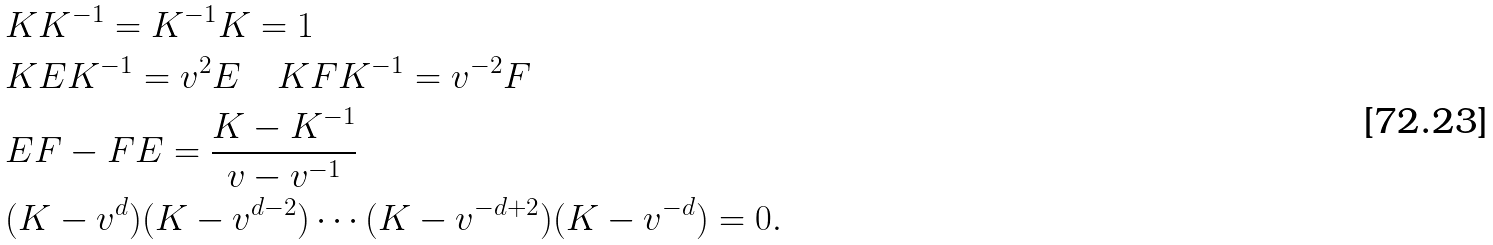<formula> <loc_0><loc_0><loc_500><loc_500>& K K ^ { - 1 } = K ^ { - 1 } K = 1 \\ & K E K ^ { - 1 } = v ^ { 2 } E \quad K F K ^ { - 1 } = v ^ { - 2 } F \\ & E F - F E = \frac { K - K ^ { - 1 } } { v - v ^ { - 1 } } \\ & ( K - v ^ { d } ) ( K - v ^ { d - 2 } ) \cdots ( K - v ^ { - d + 2 } ) ( K - v ^ { - d } ) = 0 .</formula> 